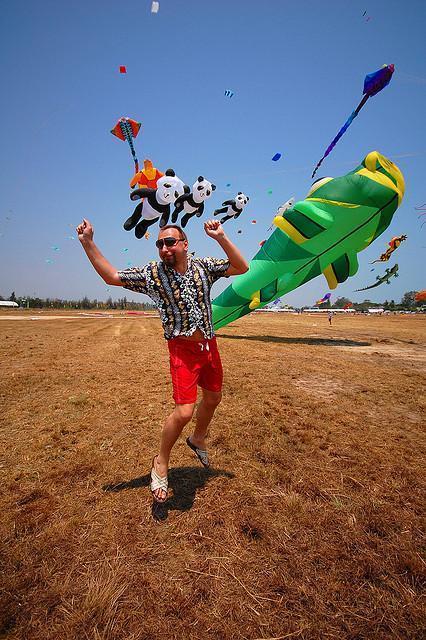How many pandas are there?
Give a very brief answer. 3. How many kites are visible?
Give a very brief answer. 2. 